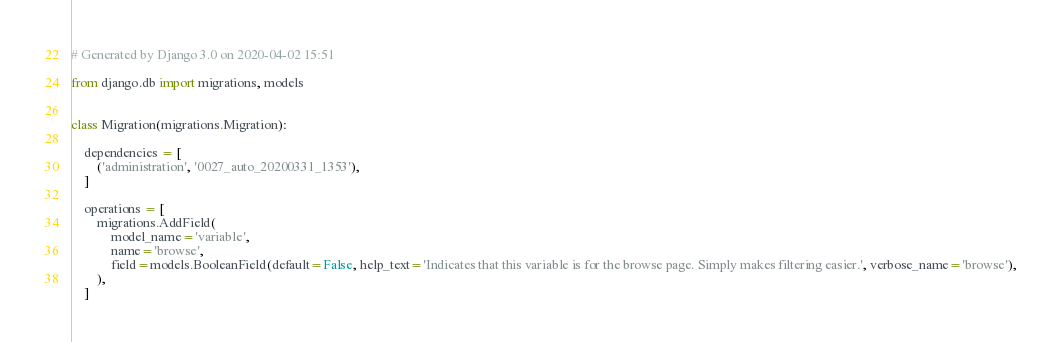<code> <loc_0><loc_0><loc_500><loc_500><_Python_># Generated by Django 3.0 on 2020-04-02 15:51

from django.db import migrations, models


class Migration(migrations.Migration):

    dependencies = [
        ('administration', '0027_auto_20200331_1353'),
    ]

    operations = [
        migrations.AddField(
            model_name='variable',
            name='browse',
            field=models.BooleanField(default=False, help_text='Indicates that this variable is for the browse page. Simply makes filtering easier.', verbose_name='browse'),
        ),
    ]
</code> 